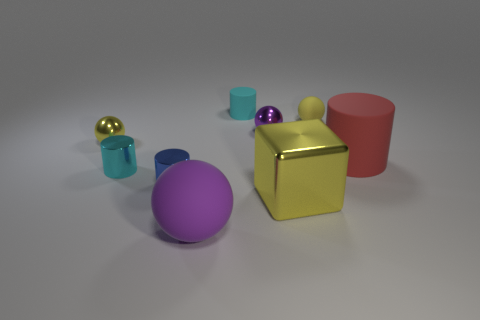How many other things are the same shape as the purple matte object?
Offer a terse response. 3. Are there any tiny purple blocks made of the same material as the large block?
Give a very brief answer. No. There is a yellow shiny thing right of the purple matte sphere; is its shape the same as the yellow matte object?
Your response must be concise. No. There is a yellow metal thing in front of the small cyan object that is left of the tiny rubber cylinder; what number of tiny purple balls are to the left of it?
Ensure brevity in your answer.  1. Is the number of yellow balls that are behind the small blue cylinder less than the number of yellow balls that are to the right of the small yellow rubber object?
Ensure brevity in your answer.  No. There is a tiny rubber thing that is the same shape as the big red matte thing; what color is it?
Provide a succinct answer. Cyan. How big is the blue cylinder?
Make the answer very short. Small. What number of purple metal balls are the same size as the cyan metallic thing?
Offer a terse response. 1. Do the tiny matte sphere and the big matte ball have the same color?
Offer a very short reply. No. Do the purple ball that is right of the small cyan rubber cylinder and the cyan cylinder right of the tiny blue cylinder have the same material?
Your answer should be very brief. No. 